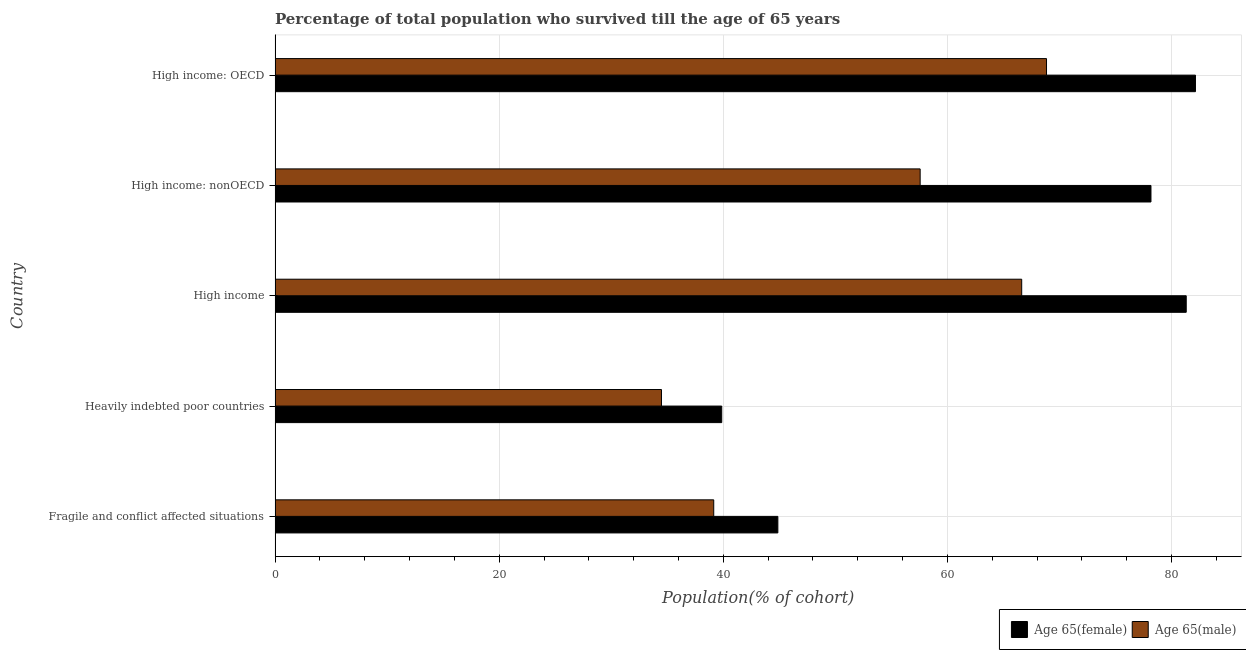Are the number of bars on each tick of the Y-axis equal?
Provide a short and direct response. Yes. How many bars are there on the 2nd tick from the bottom?
Your answer should be compact. 2. What is the label of the 4th group of bars from the top?
Make the answer very short. Heavily indebted poor countries. In how many cases, is the number of bars for a given country not equal to the number of legend labels?
Your response must be concise. 0. What is the percentage of female population who survived till age of 65 in High income: nonOECD?
Provide a succinct answer. 78.16. Across all countries, what is the maximum percentage of male population who survived till age of 65?
Your answer should be very brief. 68.84. Across all countries, what is the minimum percentage of male population who survived till age of 65?
Ensure brevity in your answer.  34.48. In which country was the percentage of male population who survived till age of 65 maximum?
Ensure brevity in your answer.  High income: OECD. In which country was the percentage of male population who survived till age of 65 minimum?
Keep it short and to the point. Heavily indebted poor countries. What is the total percentage of female population who survived till age of 65 in the graph?
Provide a succinct answer. 326.33. What is the difference between the percentage of female population who survived till age of 65 in High income: OECD and that in High income: nonOECD?
Ensure brevity in your answer.  3.97. What is the difference between the percentage of male population who survived till age of 65 in Heavily indebted poor countries and the percentage of female population who survived till age of 65 in High income: nonOECD?
Your answer should be compact. -43.68. What is the average percentage of female population who survived till age of 65 per country?
Offer a very short reply. 65.27. What is the difference between the percentage of female population who survived till age of 65 and percentage of male population who survived till age of 65 in Heavily indebted poor countries?
Your response must be concise. 5.38. What is the ratio of the percentage of male population who survived till age of 65 in Heavily indebted poor countries to that in High income: OECD?
Give a very brief answer. 0.5. What is the difference between the highest and the second highest percentage of female population who survived till age of 65?
Make the answer very short. 0.82. What is the difference between the highest and the lowest percentage of male population who survived till age of 65?
Offer a terse response. 34.36. In how many countries, is the percentage of female population who survived till age of 65 greater than the average percentage of female population who survived till age of 65 taken over all countries?
Offer a terse response. 3. What does the 2nd bar from the top in Fragile and conflict affected situations represents?
Ensure brevity in your answer.  Age 65(female). What does the 2nd bar from the bottom in High income: OECD represents?
Offer a very short reply. Age 65(male). Are all the bars in the graph horizontal?
Make the answer very short. Yes. How many countries are there in the graph?
Provide a succinct answer. 5. What is the difference between two consecutive major ticks on the X-axis?
Give a very brief answer. 20. How are the legend labels stacked?
Keep it short and to the point. Horizontal. What is the title of the graph?
Offer a terse response. Percentage of total population who survived till the age of 65 years. What is the label or title of the X-axis?
Your answer should be very brief. Population(% of cohort). What is the label or title of the Y-axis?
Give a very brief answer. Country. What is the Population(% of cohort) of Age 65(female) in Fragile and conflict affected situations?
Provide a succinct answer. 44.87. What is the Population(% of cohort) in Age 65(male) in Fragile and conflict affected situations?
Your answer should be very brief. 39.14. What is the Population(% of cohort) of Age 65(female) in Heavily indebted poor countries?
Your answer should be very brief. 39.86. What is the Population(% of cohort) in Age 65(male) in Heavily indebted poor countries?
Your answer should be very brief. 34.48. What is the Population(% of cohort) of Age 65(female) in High income?
Your response must be concise. 81.31. What is the Population(% of cohort) in Age 65(male) in High income?
Keep it short and to the point. 66.63. What is the Population(% of cohort) of Age 65(female) in High income: nonOECD?
Keep it short and to the point. 78.16. What is the Population(% of cohort) in Age 65(male) in High income: nonOECD?
Make the answer very short. 57.57. What is the Population(% of cohort) in Age 65(female) in High income: OECD?
Offer a terse response. 82.13. What is the Population(% of cohort) of Age 65(male) in High income: OECD?
Your answer should be very brief. 68.84. Across all countries, what is the maximum Population(% of cohort) in Age 65(female)?
Your answer should be compact. 82.13. Across all countries, what is the maximum Population(% of cohort) of Age 65(male)?
Your answer should be compact. 68.84. Across all countries, what is the minimum Population(% of cohort) of Age 65(female)?
Make the answer very short. 39.86. Across all countries, what is the minimum Population(% of cohort) in Age 65(male)?
Provide a succinct answer. 34.48. What is the total Population(% of cohort) in Age 65(female) in the graph?
Offer a very short reply. 326.33. What is the total Population(% of cohort) in Age 65(male) in the graph?
Provide a succinct answer. 266.66. What is the difference between the Population(% of cohort) in Age 65(female) in Fragile and conflict affected situations and that in Heavily indebted poor countries?
Offer a terse response. 5.01. What is the difference between the Population(% of cohort) of Age 65(male) in Fragile and conflict affected situations and that in Heavily indebted poor countries?
Provide a succinct answer. 4.66. What is the difference between the Population(% of cohort) in Age 65(female) in Fragile and conflict affected situations and that in High income?
Ensure brevity in your answer.  -36.44. What is the difference between the Population(% of cohort) in Age 65(male) in Fragile and conflict affected situations and that in High income?
Your answer should be compact. -27.48. What is the difference between the Population(% of cohort) of Age 65(female) in Fragile and conflict affected situations and that in High income: nonOECD?
Ensure brevity in your answer.  -33.3. What is the difference between the Population(% of cohort) of Age 65(male) in Fragile and conflict affected situations and that in High income: nonOECD?
Keep it short and to the point. -18.42. What is the difference between the Population(% of cohort) in Age 65(female) in Fragile and conflict affected situations and that in High income: OECD?
Keep it short and to the point. -37.27. What is the difference between the Population(% of cohort) of Age 65(male) in Fragile and conflict affected situations and that in High income: OECD?
Your response must be concise. -29.7. What is the difference between the Population(% of cohort) of Age 65(female) in Heavily indebted poor countries and that in High income?
Provide a short and direct response. -41.45. What is the difference between the Population(% of cohort) of Age 65(male) in Heavily indebted poor countries and that in High income?
Your response must be concise. -32.15. What is the difference between the Population(% of cohort) of Age 65(female) in Heavily indebted poor countries and that in High income: nonOECD?
Ensure brevity in your answer.  -38.31. What is the difference between the Population(% of cohort) in Age 65(male) in Heavily indebted poor countries and that in High income: nonOECD?
Provide a short and direct response. -23.08. What is the difference between the Population(% of cohort) of Age 65(female) in Heavily indebted poor countries and that in High income: OECD?
Ensure brevity in your answer.  -42.28. What is the difference between the Population(% of cohort) of Age 65(male) in Heavily indebted poor countries and that in High income: OECD?
Give a very brief answer. -34.36. What is the difference between the Population(% of cohort) in Age 65(female) in High income and that in High income: nonOECD?
Your response must be concise. 3.15. What is the difference between the Population(% of cohort) in Age 65(male) in High income and that in High income: nonOECD?
Your answer should be very brief. 9.06. What is the difference between the Population(% of cohort) in Age 65(female) in High income and that in High income: OECD?
Keep it short and to the point. -0.82. What is the difference between the Population(% of cohort) of Age 65(male) in High income and that in High income: OECD?
Offer a very short reply. -2.21. What is the difference between the Population(% of cohort) of Age 65(female) in High income: nonOECD and that in High income: OECD?
Your response must be concise. -3.97. What is the difference between the Population(% of cohort) of Age 65(male) in High income: nonOECD and that in High income: OECD?
Your answer should be very brief. -11.28. What is the difference between the Population(% of cohort) of Age 65(female) in Fragile and conflict affected situations and the Population(% of cohort) of Age 65(male) in Heavily indebted poor countries?
Your answer should be compact. 10.39. What is the difference between the Population(% of cohort) of Age 65(female) in Fragile and conflict affected situations and the Population(% of cohort) of Age 65(male) in High income?
Offer a very short reply. -21.76. What is the difference between the Population(% of cohort) of Age 65(female) in Fragile and conflict affected situations and the Population(% of cohort) of Age 65(male) in High income: nonOECD?
Ensure brevity in your answer.  -12.7. What is the difference between the Population(% of cohort) of Age 65(female) in Fragile and conflict affected situations and the Population(% of cohort) of Age 65(male) in High income: OECD?
Offer a terse response. -23.97. What is the difference between the Population(% of cohort) of Age 65(female) in Heavily indebted poor countries and the Population(% of cohort) of Age 65(male) in High income?
Provide a succinct answer. -26.77. What is the difference between the Population(% of cohort) in Age 65(female) in Heavily indebted poor countries and the Population(% of cohort) in Age 65(male) in High income: nonOECD?
Ensure brevity in your answer.  -17.71. What is the difference between the Population(% of cohort) of Age 65(female) in Heavily indebted poor countries and the Population(% of cohort) of Age 65(male) in High income: OECD?
Your response must be concise. -28.98. What is the difference between the Population(% of cohort) in Age 65(female) in High income and the Population(% of cohort) in Age 65(male) in High income: nonOECD?
Give a very brief answer. 23.74. What is the difference between the Population(% of cohort) in Age 65(female) in High income and the Population(% of cohort) in Age 65(male) in High income: OECD?
Ensure brevity in your answer.  12.47. What is the difference between the Population(% of cohort) of Age 65(female) in High income: nonOECD and the Population(% of cohort) of Age 65(male) in High income: OECD?
Keep it short and to the point. 9.32. What is the average Population(% of cohort) of Age 65(female) per country?
Make the answer very short. 65.27. What is the average Population(% of cohort) in Age 65(male) per country?
Give a very brief answer. 53.33. What is the difference between the Population(% of cohort) of Age 65(female) and Population(% of cohort) of Age 65(male) in Fragile and conflict affected situations?
Your answer should be compact. 5.72. What is the difference between the Population(% of cohort) of Age 65(female) and Population(% of cohort) of Age 65(male) in Heavily indebted poor countries?
Ensure brevity in your answer.  5.38. What is the difference between the Population(% of cohort) of Age 65(female) and Population(% of cohort) of Age 65(male) in High income?
Your response must be concise. 14.68. What is the difference between the Population(% of cohort) of Age 65(female) and Population(% of cohort) of Age 65(male) in High income: nonOECD?
Your answer should be compact. 20.6. What is the difference between the Population(% of cohort) of Age 65(female) and Population(% of cohort) of Age 65(male) in High income: OECD?
Give a very brief answer. 13.29. What is the ratio of the Population(% of cohort) of Age 65(female) in Fragile and conflict affected situations to that in Heavily indebted poor countries?
Give a very brief answer. 1.13. What is the ratio of the Population(% of cohort) of Age 65(male) in Fragile and conflict affected situations to that in Heavily indebted poor countries?
Give a very brief answer. 1.14. What is the ratio of the Population(% of cohort) in Age 65(female) in Fragile and conflict affected situations to that in High income?
Keep it short and to the point. 0.55. What is the ratio of the Population(% of cohort) in Age 65(male) in Fragile and conflict affected situations to that in High income?
Offer a terse response. 0.59. What is the ratio of the Population(% of cohort) of Age 65(female) in Fragile and conflict affected situations to that in High income: nonOECD?
Offer a very short reply. 0.57. What is the ratio of the Population(% of cohort) of Age 65(male) in Fragile and conflict affected situations to that in High income: nonOECD?
Ensure brevity in your answer.  0.68. What is the ratio of the Population(% of cohort) in Age 65(female) in Fragile and conflict affected situations to that in High income: OECD?
Your answer should be very brief. 0.55. What is the ratio of the Population(% of cohort) of Age 65(male) in Fragile and conflict affected situations to that in High income: OECD?
Make the answer very short. 0.57. What is the ratio of the Population(% of cohort) in Age 65(female) in Heavily indebted poor countries to that in High income?
Give a very brief answer. 0.49. What is the ratio of the Population(% of cohort) in Age 65(male) in Heavily indebted poor countries to that in High income?
Provide a short and direct response. 0.52. What is the ratio of the Population(% of cohort) in Age 65(female) in Heavily indebted poor countries to that in High income: nonOECD?
Give a very brief answer. 0.51. What is the ratio of the Population(% of cohort) in Age 65(male) in Heavily indebted poor countries to that in High income: nonOECD?
Give a very brief answer. 0.6. What is the ratio of the Population(% of cohort) in Age 65(female) in Heavily indebted poor countries to that in High income: OECD?
Offer a very short reply. 0.49. What is the ratio of the Population(% of cohort) in Age 65(male) in Heavily indebted poor countries to that in High income: OECD?
Give a very brief answer. 0.5. What is the ratio of the Population(% of cohort) in Age 65(female) in High income to that in High income: nonOECD?
Your answer should be compact. 1.04. What is the ratio of the Population(% of cohort) of Age 65(male) in High income to that in High income: nonOECD?
Offer a very short reply. 1.16. What is the ratio of the Population(% of cohort) of Age 65(male) in High income to that in High income: OECD?
Offer a very short reply. 0.97. What is the ratio of the Population(% of cohort) in Age 65(female) in High income: nonOECD to that in High income: OECD?
Provide a succinct answer. 0.95. What is the ratio of the Population(% of cohort) in Age 65(male) in High income: nonOECD to that in High income: OECD?
Provide a succinct answer. 0.84. What is the difference between the highest and the second highest Population(% of cohort) of Age 65(female)?
Ensure brevity in your answer.  0.82. What is the difference between the highest and the second highest Population(% of cohort) of Age 65(male)?
Your answer should be compact. 2.21. What is the difference between the highest and the lowest Population(% of cohort) in Age 65(female)?
Provide a succinct answer. 42.28. What is the difference between the highest and the lowest Population(% of cohort) of Age 65(male)?
Offer a terse response. 34.36. 